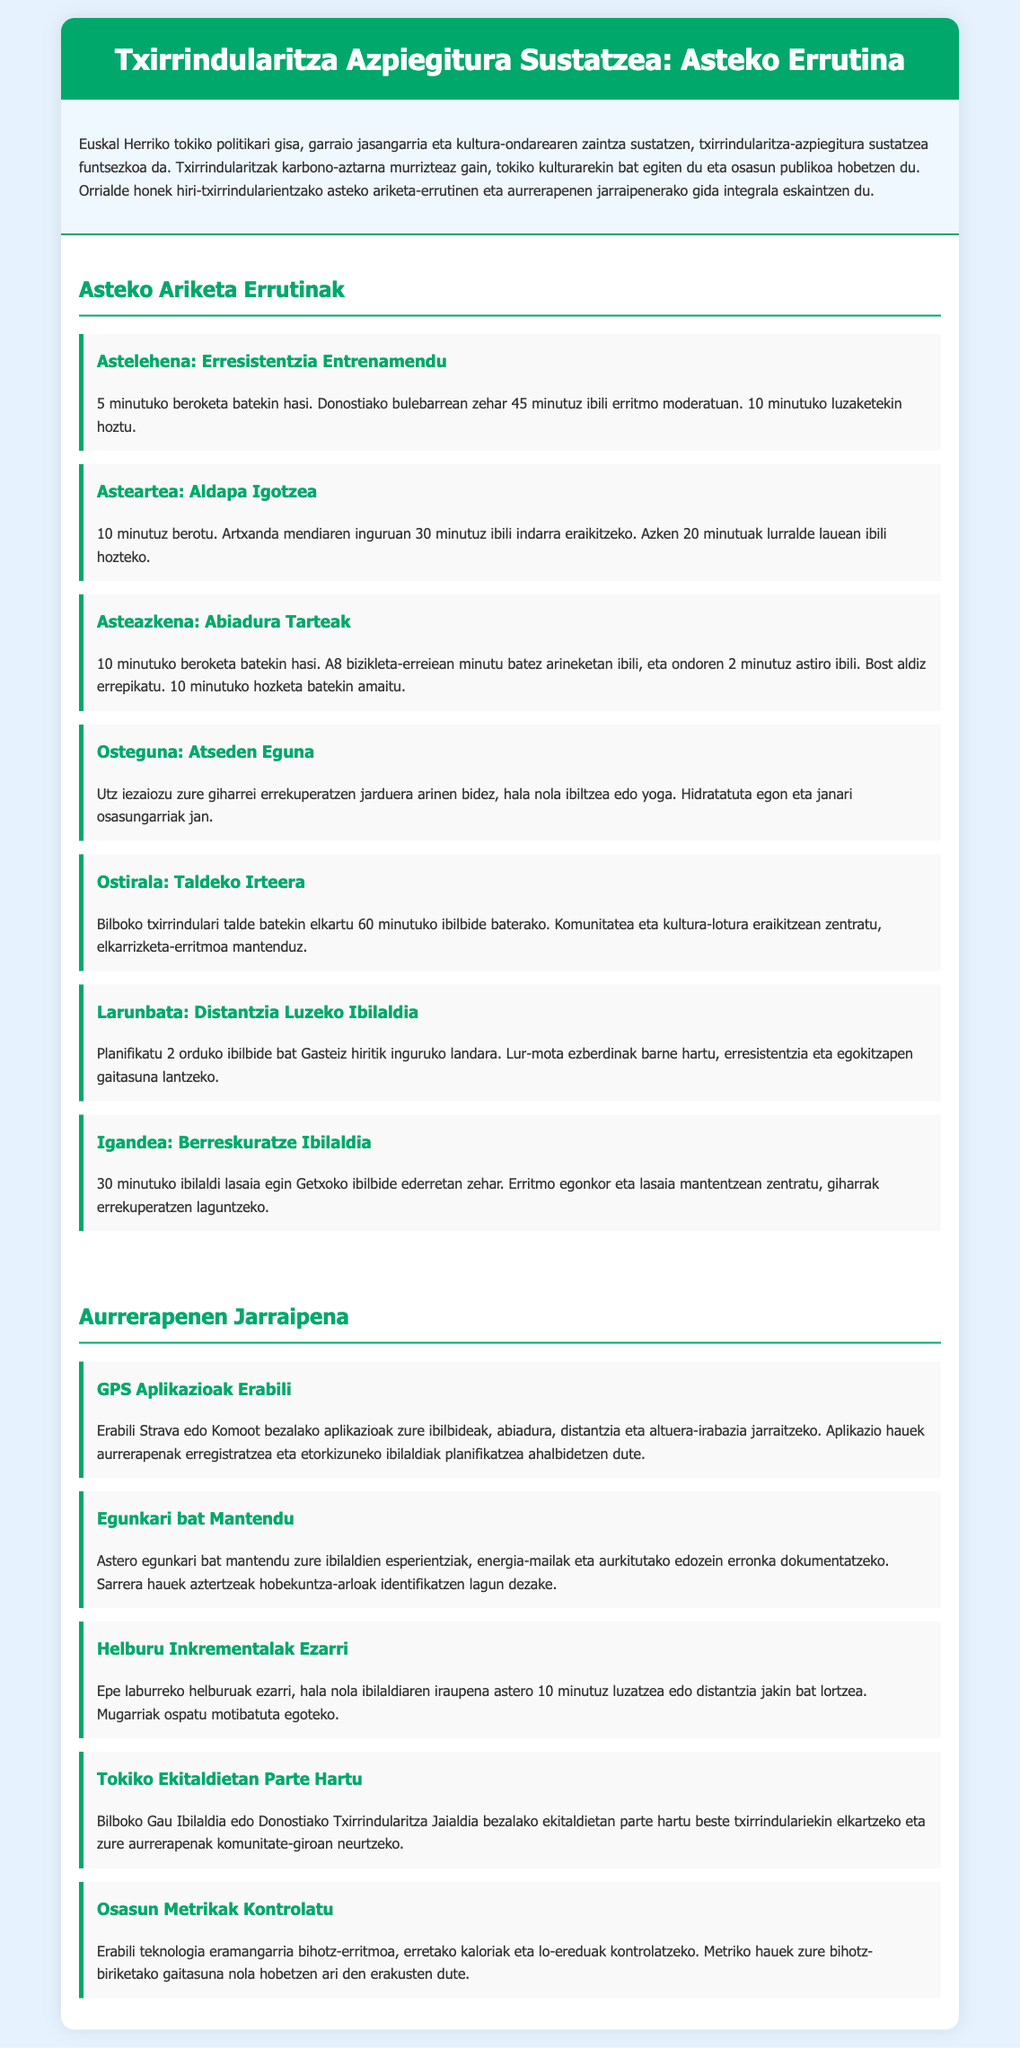What is the purpose of promoting cycling infrastructure? The document explains that promoting cycling infrastructure is crucial for sustainable transport, cultural heritage preservation, and improving public health.
Answer: Sustainable transport How long should the Monday exercise routine last? The Monday routine specifies a walking duration of 45 minutes after a 5-minute warm-up.
Answer: 45 minutes What type of training is focused on Tuesday? The Tuesday routine emphasizes strength building through hill climbing.
Answer: Hill climbing How many times should the speed intervals be repeated on Wednesday? The Wednesday exercise mentions that speed intervals should be repeated five times.
Answer: Five times What should be maintained during Sunday’s recovery walk? The Sunday routine states that a steady and relaxed pace should be maintained.
Answer: Steady and relaxed pace What is a recommended activity for Thursday? The document suggests light activities such as walking or yoga for recovery on Thursday.
Answer: Walking or yoga Which applications are suggested for tracking progress? The document recommends using GPS applications like Strava or Komoot for tracking rides and progress.
Answer: Strava or Komoot What should be documented in the weekly journal? The weekly journal should document walking experiences, energy levels, and any challenges encountered.
Answer: Experiences, energy levels, challenges What is an example of an incremental goal to set? An incremental goal mentioned is to increase walk duration by 10 minutes each week.
Answer: 10 minutes 